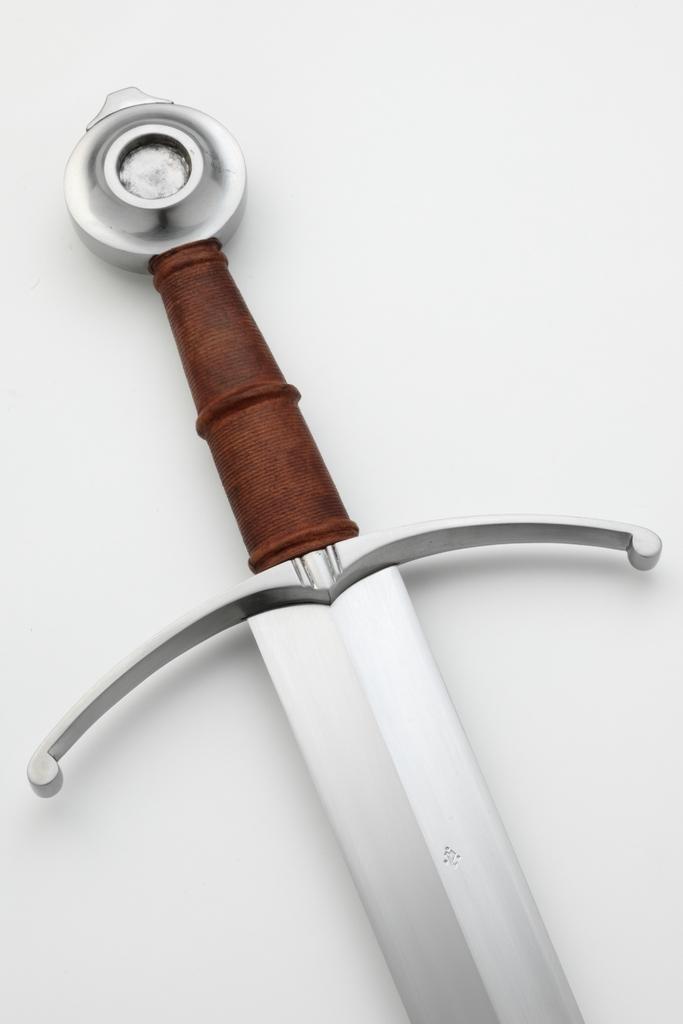Please provide a concise description of this image. Here we can see a sword on a white platform and the handle of it is brown in color. 